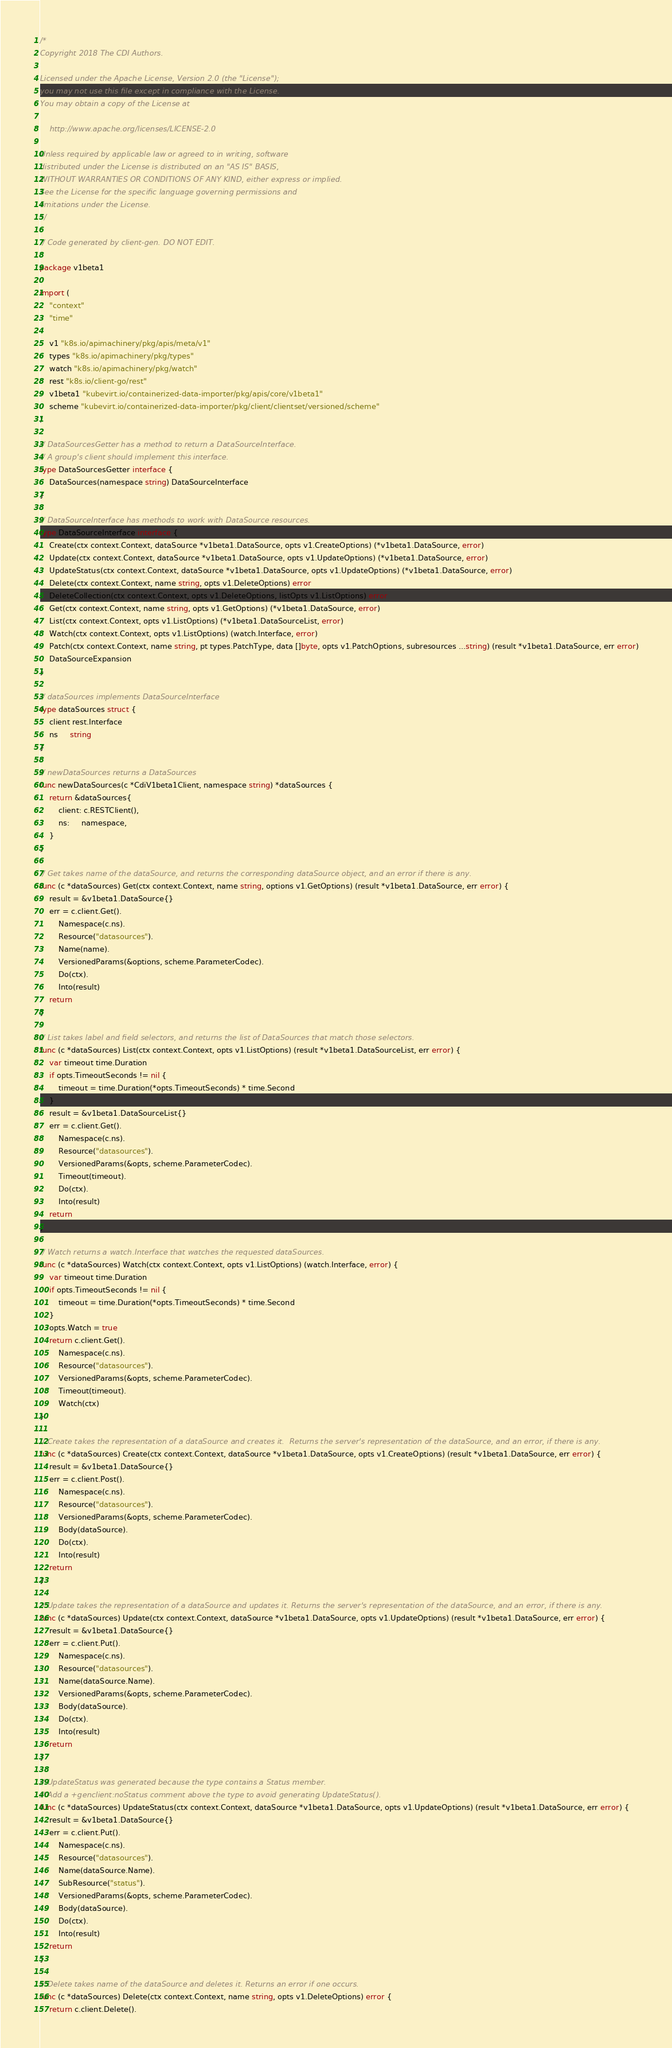<code> <loc_0><loc_0><loc_500><loc_500><_Go_>/*
Copyright 2018 The CDI Authors.

Licensed under the Apache License, Version 2.0 (the "License");
you may not use this file except in compliance with the License.
You may obtain a copy of the License at

    http://www.apache.org/licenses/LICENSE-2.0

Unless required by applicable law or agreed to in writing, software
distributed under the License is distributed on an "AS IS" BASIS,
WITHOUT WARRANTIES OR CONDITIONS OF ANY KIND, either express or implied.
See the License for the specific language governing permissions and
limitations under the License.
*/

// Code generated by client-gen. DO NOT EDIT.

package v1beta1

import (
	"context"
	"time"

	v1 "k8s.io/apimachinery/pkg/apis/meta/v1"
	types "k8s.io/apimachinery/pkg/types"
	watch "k8s.io/apimachinery/pkg/watch"
	rest "k8s.io/client-go/rest"
	v1beta1 "kubevirt.io/containerized-data-importer/pkg/apis/core/v1beta1"
	scheme "kubevirt.io/containerized-data-importer/pkg/client/clientset/versioned/scheme"
)

// DataSourcesGetter has a method to return a DataSourceInterface.
// A group's client should implement this interface.
type DataSourcesGetter interface {
	DataSources(namespace string) DataSourceInterface
}

// DataSourceInterface has methods to work with DataSource resources.
type DataSourceInterface interface {
	Create(ctx context.Context, dataSource *v1beta1.DataSource, opts v1.CreateOptions) (*v1beta1.DataSource, error)
	Update(ctx context.Context, dataSource *v1beta1.DataSource, opts v1.UpdateOptions) (*v1beta1.DataSource, error)
	UpdateStatus(ctx context.Context, dataSource *v1beta1.DataSource, opts v1.UpdateOptions) (*v1beta1.DataSource, error)
	Delete(ctx context.Context, name string, opts v1.DeleteOptions) error
	DeleteCollection(ctx context.Context, opts v1.DeleteOptions, listOpts v1.ListOptions) error
	Get(ctx context.Context, name string, opts v1.GetOptions) (*v1beta1.DataSource, error)
	List(ctx context.Context, opts v1.ListOptions) (*v1beta1.DataSourceList, error)
	Watch(ctx context.Context, opts v1.ListOptions) (watch.Interface, error)
	Patch(ctx context.Context, name string, pt types.PatchType, data []byte, opts v1.PatchOptions, subresources ...string) (result *v1beta1.DataSource, err error)
	DataSourceExpansion
}

// dataSources implements DataSourceInterface
type dataSources struct {
	client rest.Interface
	ns     string
}

// newDataSources returns a DataSources
func newDataSources(c *CdiV1beta1Client, namespace string) *dataSources {
	return &dataSources{
		client: c.RESTClient(),
		ns:     namespace,
	}
}

// Get takes name of the dataSource, and returns the corresponding dataSource object, and an error if there is any.
func (c *dataSources) Get(ctx context.Context, name string, options v1.GetOptions) (result *v1beta1.DataSource, err error) {
	result = &v1beta1.DataSource{}
	err = c.client.Get().
		Namespace(c.ns).
		Resource("datasources").
		Name(name).
		VersionedParams(&options, scheme.ParameterCodec).
		Do(ctx).
		Into(result)
	return
}

// List takes label and field selectors, and returns the list of DataSources that match those selectors.
func (c *dataSources) List(ctx context.Context, opts v1.ListOptions) (result *v1beta1.DataSourceList, err error) {
	var timeout time.Duration
	if opts.TimeoutSeconds != nil {
		timeout = time.Duration(*opts.TimeoutSeconds) * time.Second
	}
	result = &v1beta1.DataSourceList{}
	err = c.client.Get().
		Namespace(c.ns).
		Resource("datasources").
		VersionedParams(&opts, scheme.ParameterCodec).
		Timeout(timeout).
		Do(ctx).
		Into(result)
	return
}

// Watch returns a watch.Interface that watches the requested dataSources.
func (c *dataSources) Watch(ctx context.Context, opts v1.ListOptions) (watch.Interface, error) {
	var timeout time.Duration
	if opts.TimeoutSeconds != nil {
		timeout = time.Duration(*opts.TimeoutSeconds) * time.Second
	}
	opts.Watch = true
	return c.client.Get().
		Namespace(c.ns).
		Resource("datasources").
		VersionedParams(&opts, scheme.ParameterCodec).
		Timeout(timeout).
		Watch(ctx)
}

// Create takes the representation of a dataSource and creates it.  Returns the server's representation of the dataSource, and an error, if there is any.
func (c *dataSources) Create(ctx context.Context, dataSource *v1beta1.DataSource, opts v1.CreateOptions) (result *v1beta1.DataSource, err error) {
	result = &v1beta1.DataSource{}
	err = c.client.Post().
		Namespace(c.ns).
		Resource("datasources").
		VersionedParams(&opts, scheme.ParameterCodec).
		Body(dataSource).
		Do(ctx).
		Into(result)
	return
}

// Update takes the representation of a dataSource and updates it. Returns the server's representation of the dataSource, and an error, if there is any.
func (c *dataSources) Update(ctx context.Context, dataSource *v1beta1.DataSource, opts v1.UpdateOptions) (result *v1beta1.DataSource, err error) {
	result = &v1beta1.DataSource{}
	err = c.client.Put().
		Namespace(c.ns).
		Resource("datasources").
		Name(dataSource.Name).
		VersionedParams(&opts, scheme.ParameterCodec).
		Body(dataSource).
		Do(ctx).
		Into(result)
	return
}

// UpdateStatus was generated because the type contains a Status member.
// Add a +genclient:noStatus comment above the type to avoid generating UpdateStatus().
func (c *dataSources) UpdateStatus(ctx context.Context, dataSource *v1beta1.DataSource, opts v1.UpdateOptions) (result *v1beta1.DataSource, err error) {
	result = &v1beta1.DataSource{}
	err = c.client.Put().
		Namespace(c.ns).
		Resource("datasources").
		Name(dataSource.Name).
		SubResource("status").
		VersionedParams(&opts, scheme.ParameterCodec).
		Body(dataSource).
		Do(ctx).
		Into(result)
	return
}

// Delete takes name of the dataSource and deletes it. Returns an error if one occurs.
func (c *dataSources) Delete(ctx context.Context, name string, opts v1.DeleteOptions) error {
	return c.client.Delete().</code> 